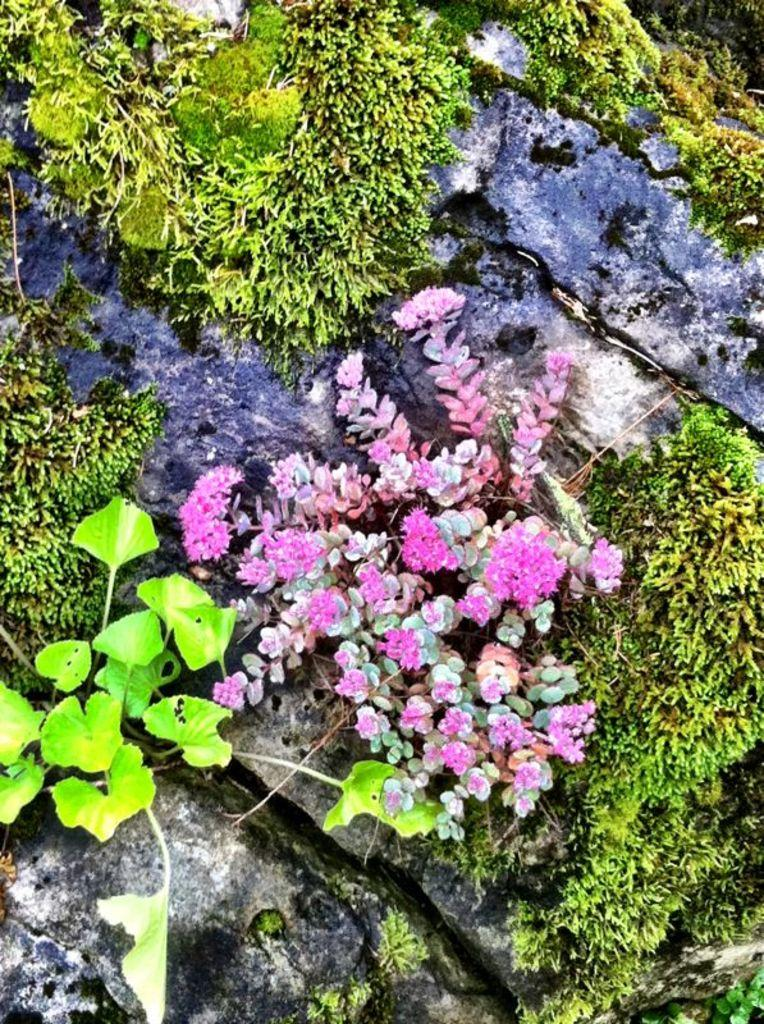What type of plants can be seen in the image? There are flowers in the image. What type of vegetation is present in the image besides flowers? There is grass in the image. What other objects can be seen in the image? There are rocks in the image. What type of rice can be seen in the image? There is no rice present in the image. How many rolls are visible in the image? There are no rolls present in the image. 